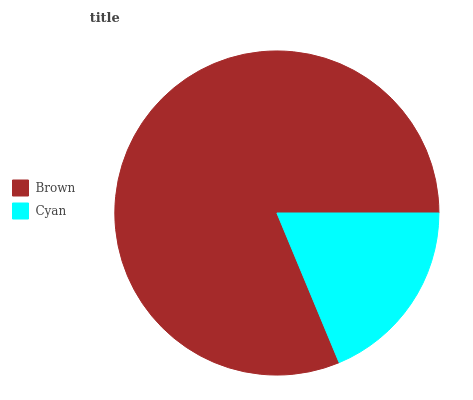Is Cyan the minimum?
Answer yes or no. Yes. Is Brown the maximum?
Answer yes or no. Yes. Is Cyan the maximum?
Answer yes or no. No. Is Brown greater than Cyan?
Answer yes or no. Yes. Is Cyan less than Brown?
Answer yes or no. Yes. Is Cyan greater than Brown?
Answer yes or no. No. Is Brown less than Cyan?
Answer yes or no. No. Is Brown the high median?
Answer yes or no. Yes. Is Cyan the low median?
Answer yes or no. Yes. Is Cyan the high median?
Answer yes or no. No. Is Brown the low median?
Answer yes or no. No. 